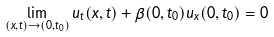Convert formula to latex. <formula><loc_0><loc_0><loc_500><loc_500>\lim _ { ( x , t ) \to ( 0 , t _ { 0 } ) } u _ { t } ( x , t ) + \beta ( 0 , t _ { 0 } ) u _ { x } ( 0 , t _ { 0 } ) = 0</formula> 